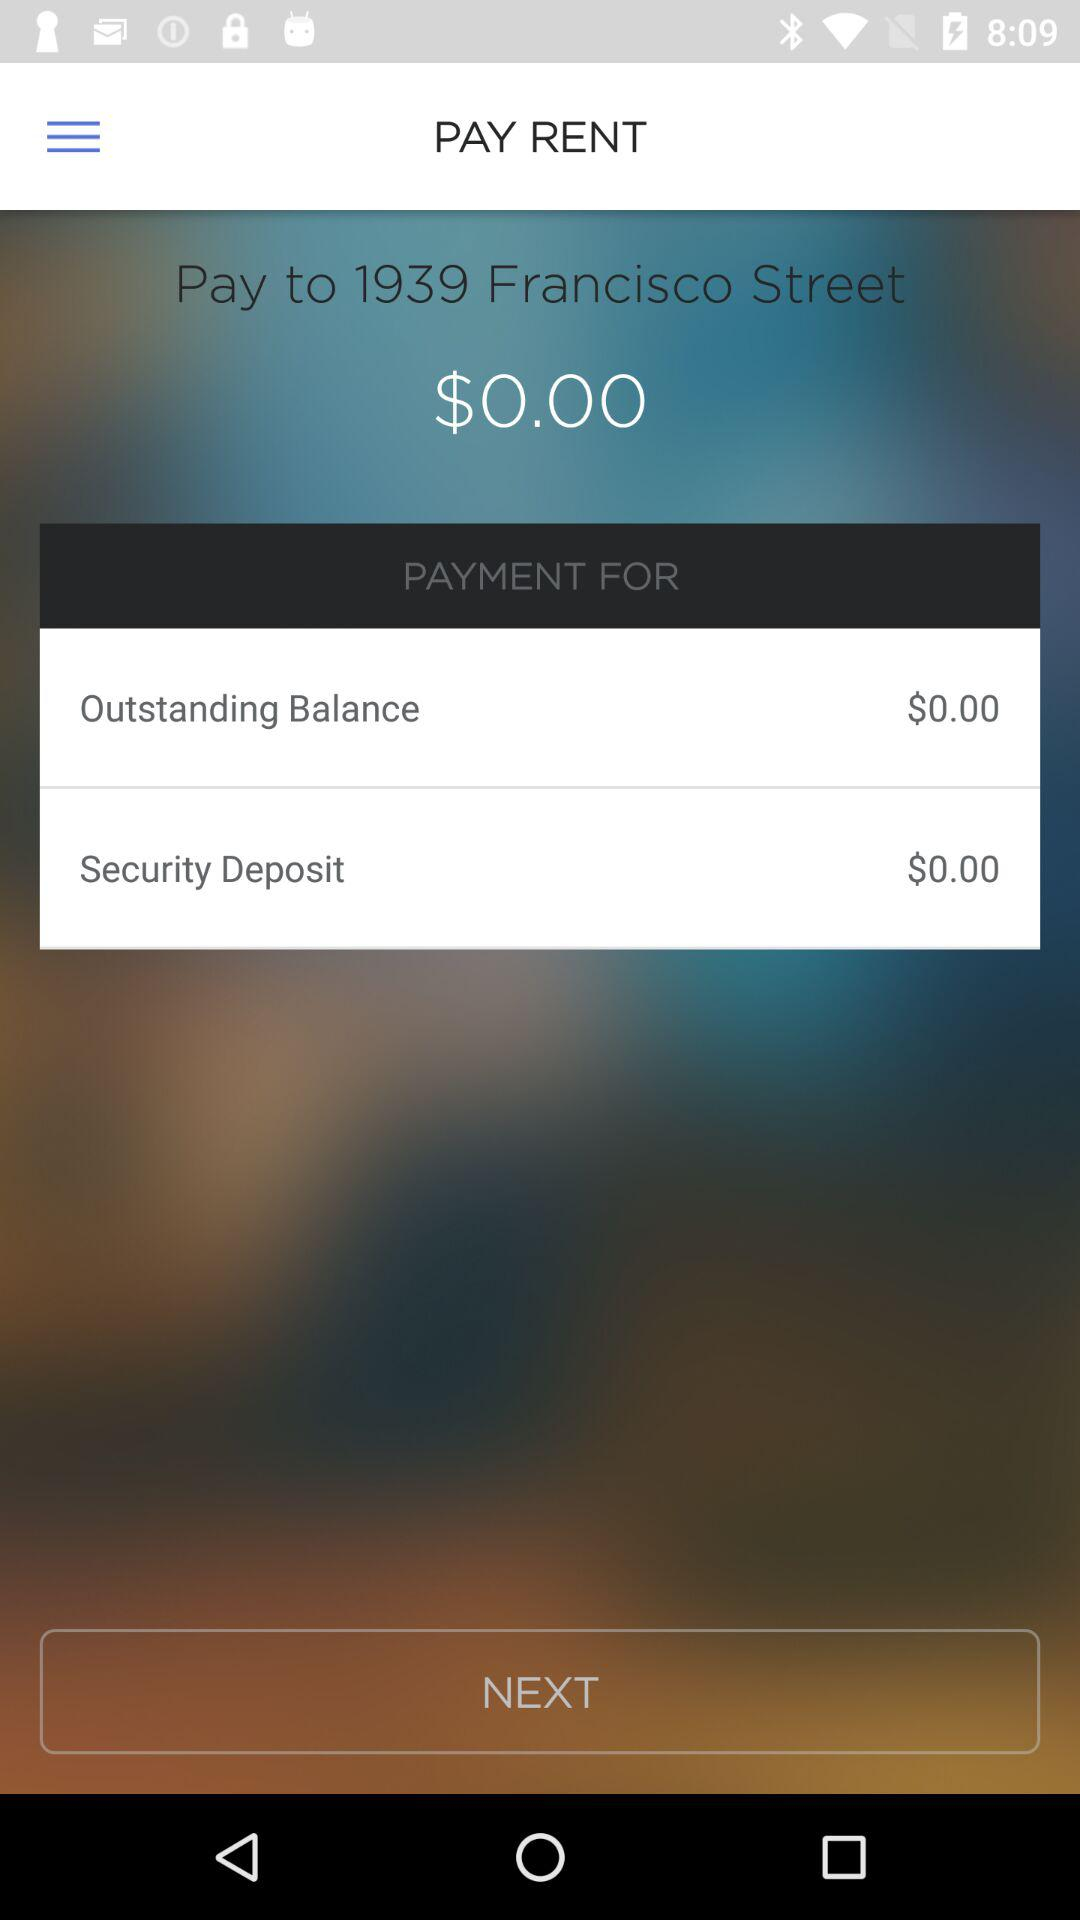How much is the outstanding balance? The outstanding balance is 0 dollars. 